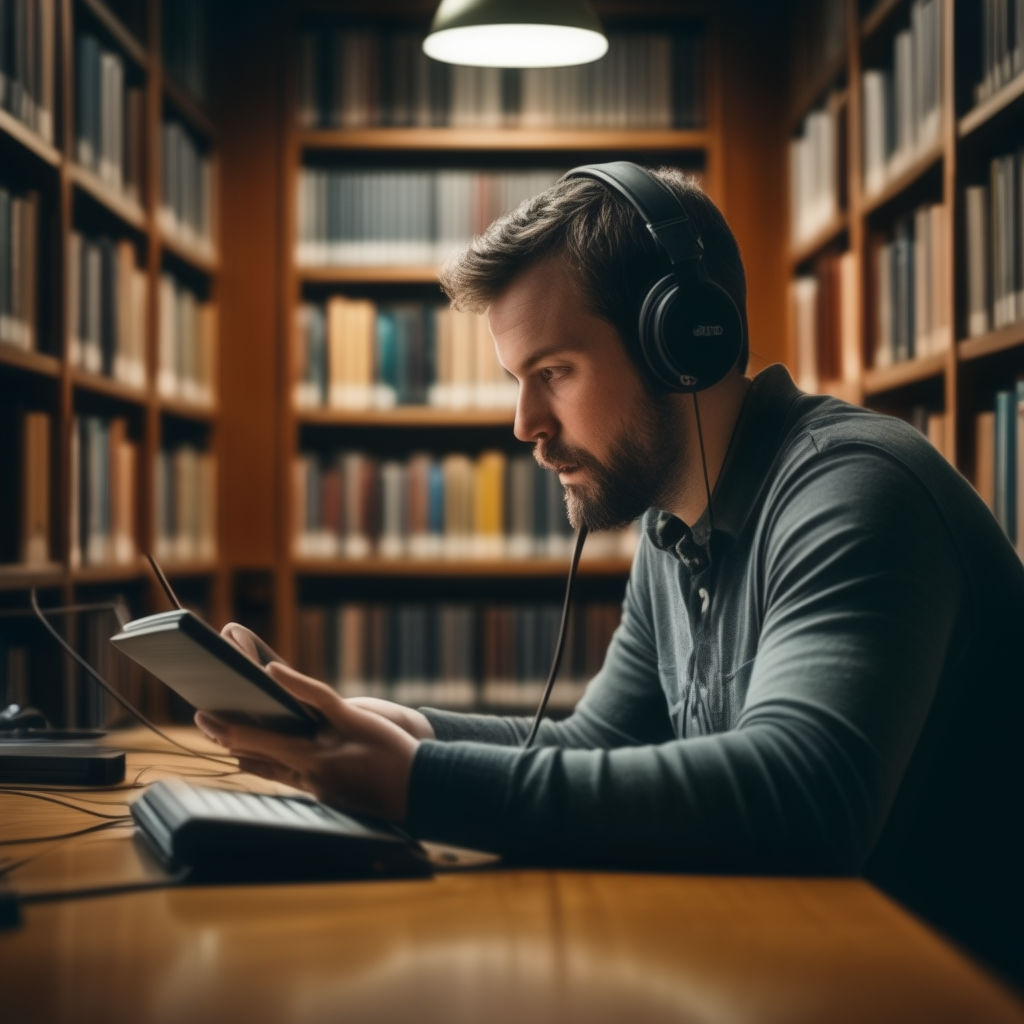A man stands on the roof of a house and looks at the moon while holding a book  A man is sitting in a library, wearing headphones and looking at a tablet. 